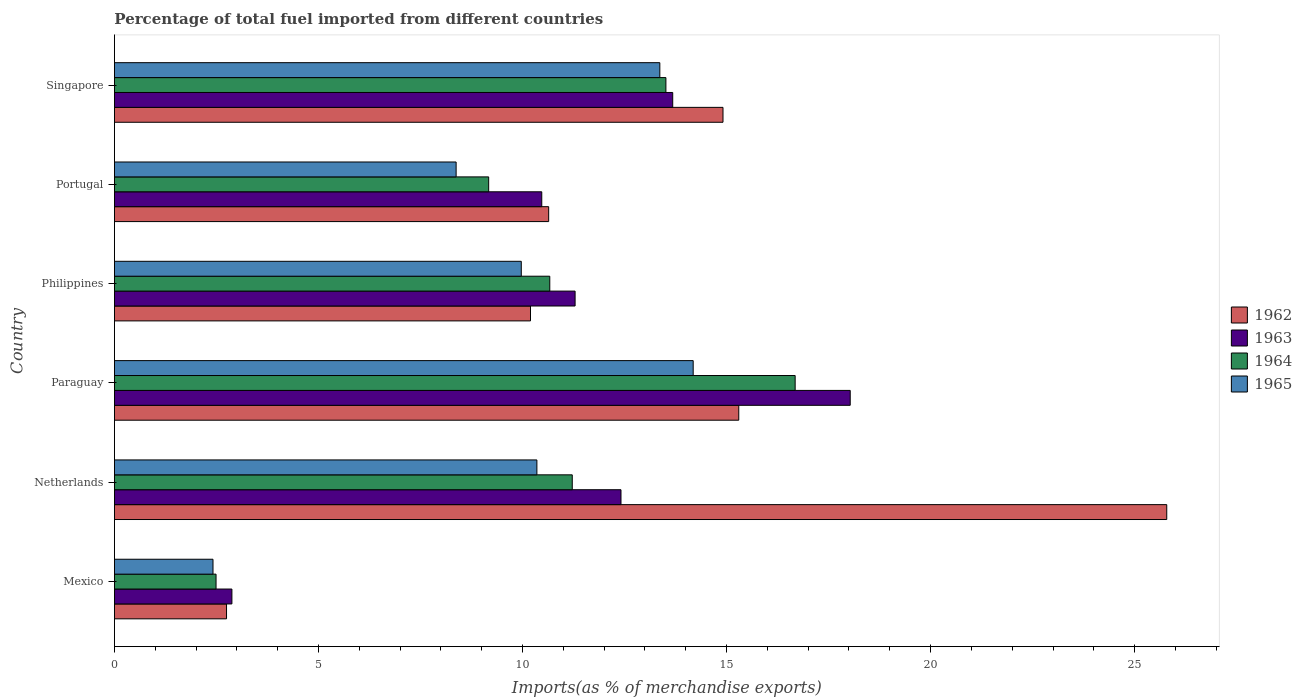How many groups of bars are there?
Provide a succinct answer. 6. Are the number of bars per tick equal to the number of legend labels?
Keep it short and to the point. Yes. Are the number of bars on each tick of the Y-axis equal?
Offer a terse response. Yes. How many bars are there on the 5th tick from the bottom?
Ensure brevity in your answer.  4. What is the label of the 1st group of bars from the top?
Ensure brevity in your answer.  Singapore. What is the percentage of imports to different countries in 1965 in Netherlands?
Provide a short and direct response. 10.35. Across all countries, what is the maximum percentage of imports to different countries in 1964?
Ensure brevity in your answer.  16.68. Across all countries, what is the minimum percentage of imports to different countries in 1965?
Make the answer very short. 2.42. In which country was the percentage of imports to different countries in 1963 maximum?
Provide a short and direct response. Paraguay. In which country was the percentage of imports to different countries in 1965 minimum?
Your response must be concise. Mexico. What is the total percentage of imports to different countries in 1963 in the graph?
Your answer should be very brief. 68.76. What is the difference between the percentage of imports to different countries in 1963 in Mexico and that in Netherlands?
Provide a short and direct response. -9.53. What is the difference between the percentage of imports to different countries in 1964 in Portugal and the percentage of imports to different countries in 1963 in Singapore?
Keep it short and to the point. -4.51. What is the average percentage of imports to different countries in 1963 per country?
Your answer should be compact. 11.46. What is the difference between the percentage of imports to different countries in 1962 and percentage of imports to different countries in 1964 in Mexico?
Keep it short and to the point. 0.26. What is the ratio of the percentage of imports to different countries in 1964 in Mexico to that in Singapore?
Your response must be concise. 0.18. Is the percentage of imports to different countries in 1962 in Philippines less than that in Portugal?
Make the answer very short. Yes. Is the difference between the percentage of imports to different countries in 1962 in Paraguay and Singapore greater than the difference between the percentage of imports to different countries in 1964 in Paraguay and Singapore?
Make the answer very short. No. What is the difference between the highest and the second highest percentage of imports to different countries in 1962?
Keep it short and to the point. 10.49. What is the difference between the highest and the lowest percentage of imports to different countries in 1965?
Keep it short and to the point. 11.77. Is it the case that in every country, the sum of the percentage of imports to different countries in 1965 and percentage of imports to different countries in 1962 is greater than the sum of percentage of imports to different countries in 1964 and percentage of imports to different countries in 1963?
Provide a short and direct response. No. What does the 4th bar from the bottom in Netherlands represents?
Make the answer very short. 1965. Is it the case that in every country, the sum of the percentage of imports to different countries in 1964 and percentage of imports to different countries in 1963 is greater than the percentage of imports to different countries in 1965?
Your answer should be compact. Yes. How many bars are there?
Offer a terse response. 24. Are all the bars in the graph horizontal?
Provide a succinct answer. Yes. Are the values on the major ticks of X-axis written in scientific E-notation?
Provide a short and direct response. No. Does the graph contain any zero values?
Keep it short and to the point. No. Does the graph contain grids?
Give a very brief answer. No. Where does the legend appear in the graph?
Keep it short and to the point. Center right. How many legend labels are there?
Ensure brevity in your answer.  4. How are the legend labels stacked?
Provide a succinct answer. Vertical. What is the title of the graph?
Your answer should be compact. Percentage of total fuel imported from different countries. What is the label or title of the X-axis?
Your answer should be compact. Imports(as % of merchandise exports). What is the Imports(as % of merchandise exports) of 1962 in Mexico?
Provide a succinct answer. 2.75. What is the Imports(as % of merchandise exports) in 1963 in Mexico?
Provide a succinct answer. 2.88. What is the Imports(as % of merchandise exports) in 1964 in Mexico?
Offer a terse response. 2.49. What is the Imports(as % of merchandise exports) in 1965 in Mexico?
Offer a terse response. 2.42. What is the Imports(as % of merchandise exports) in 1962 in Netherlands?
Your answer should be very brief. 25.79. What is the Imports(as % of merchandise exports) in 1963 in Netherlands?
Offer a very short reply. 12.41. What is the Imports(as % of merchandise exports) in 1964 in Netherlands?
Offer a terse response. 11.22. What is the Imports(as % of merchandise exports) of 1965 in Netherlands?
Your response must be concise. 10.35. What is the Imports(as % of merchandise exports) of 1962 in Paraguay?
Provide a short and direct response. 15.3. What is the Imports(as % of merchandise exports) in 1963 in Paraguay?
Your answer should be compact. 18.03. What is the Imports(as % of merchandise exports) in 1964 in Paraguay?
Give a very brief answer. 16.68. What is the Imports(as % of merchandise exports) in 1965 in Paraguay?
Your answer should be compact. 14.18. What is the Imports(as % of merchandise exports) of 1962 in Philippines?
Make the answer very short. 10.2. What is the Imports(as % of merchandise exports) in 1963 in Philippines?
Offer a terse response. 11.29. What is the Imports(as % of merchandise exports) in 1964 in Philippines?
Provide a succinct answer. 10.67. What is the Imports(as % of merchandise exports) of 1965 in Philippines?
Ensure brevity in your answer.  9.97. What is the Imports(as % of merchandise exports) of 1962 in Portugal?
Keep it short and to the point. 10.64. What is the Imports(as % of merchandise exports) in 1963 in Portugal?
Offer a terse response. 10.47. What is the Imports(as % of merchandise exports) in 1964 in Portugal?
Provide a short and direct response. 9.17. What is the Imports(as % of merchandise exports) in 1965 in Portugal?
Give a very brief answer. 8.37. What is the Imports(as % of merchandise exports) in 1962 in Singapore?
Your answer should be very brief. 14.91. What is the Imports(as % of merchandise exports) in 1963 in Singapore?
Provide a succinct answer. 13.68. What is the Imports(as % of merchandise exports) of 1964 in Singapore?
Keep it short and to the point. 13.51. What is the Imports(as % of merchandise exports) of 1965 in Singapore?
Give a very brief answer. 13.37. Across all countries, what is the maximum Imports(as % of merchandise exports) in 1962?
Make the answer very short. 25.79. Across all countries, what is the maximum Imports(as % of merchandise exports) in 1963?
Your response must be concise. 18.03. Across all countries, what is the maximum Imports(as % of merchandise exports) of 1964?
Offer a very short reply. 16.68. Across all countries, what is the maximum Imports(as % of merchandise exports) of 1965?
Keep it short and to the point. 14.18. Across all countries, what is the minimum Imports(as % of merchandise exports) of 1962?
Provide a short and direct response. 2.75. Across all countries, what is the minimum Imports(as % of merchandise exports) of 1963?
Offer a terse response. 2.88. Across all countries, what is the minimum Imports(as % of merchandise exports) of 1964?
Offer a terse response. 2.49. Across all countries, what is the minimum Imports(as % of merchandise exports) of 1965?
Provide a succinct answer. 2.42. What is the total Imports(as % of merchandise exports) in 1962 in the graph?
Your response must be concise. 79.58. What is the total Imports(as % of merchandise exports) of 1963 in the graph?
Your response must be concise. 68.76. What is the total Imports(as % of merchandise exports) of 1964 in the graph?
Give a very brief answer. 63.74. What is the total Imports(as % of merchandise exports) of 1965 in the graph?
Your answer should be compact. 58.66. What is the difference between the Imports(as % of merchandise exports) of 1962 in Mexico and that in Netherlands?
Provide a succinct answer. -23.04. What is the difference between the Imports(as % of merchandise exports) in 1963 in Mexico and that in Netherlands?
Offer a terse response. -9.53. What is the difference between the Imports(as % of merchandise exports) in 1964 in Mexico and that in Netherlands?
Offer a terse response. -8.73. What is the difference between the Imports(as % of merchandise exports) in 1965 in Mexico and that in Netherlands?
Offer a very short reply. -7.94. What is the difference between the Imports(as % of merchandise exports) of 1962 in Mexico and that in Paraguay?
Keep it short and to the point. -12.55. What is the difference between the Imports(as % of merchandise exports) of 1963 in Mexico and that in Paraguay?
Ensure brevity in your answer.  -15.15. What is the difference between the Imports(as % of merchandise exports) of 1964 in Mexico and that in Paraguay?
Keep it short and to the point. -14.19. What is the difference between the Imports(as % of merchandise exports) in 1965 in Mexico and that in Paraguay?
Ensure brevity in your answer.  -11.77. What is the difference between the Imports(as % of merchandise exports) in 1962 in Mexico and that in Philippines?
Offer a terse response. -7.45. What is the difference between the Imports(as % of merchandise exports) in 1963 in Mexico and that in Philippines?
Ensure brevity in your answer.  -8.41. What is the difference between the Imports(as % of merchandise exports) in 1964 in Mexico and that in Philippines?
Make the answer very short. -8.18. What is the difference between the Imports(as % of merchandise exports) in 1965 in Mexico and that in Philippines?
Keep it short and to the point. -7.55. What is the difference between the Imports(as % of merchandise exports) in 1962 in Mexico and that in Portugal?
Offer a terse response. -7.89. What is the difference between the Imports(as % of merchandise exports) in 1963 in Mexico and that in Portugal?
Your answer should be compact. -7.59. What is the difference between the Imports(as % of merchandise exports) in 1964 in Mexico and that in Portugal?
Give a very brief answer. -6.68. What is the difference between the Imports(as % of merchandise exports) of 1965 in Mexico and that in Portugal?
Your answer should be compact. -5.96. What is the difference between the Imports(as % of merchandise exports) in 1962 in Mexico and that in Singapore?
Ensure brevity in your answer.  -12.17. What is the difference between the Imports(as % of merchandise exports) of 1963 in Mexico and that in Singapore?
Offer a terse response. -10.8. What is the difference between the Imports(as % of merchandise exports) in 1964 in Mexico and that in Singapore?
Keep it short and to the point. -11.02. What is the difference between the Imports(as % of merchandise exports) in 1965 in Mexico and that in Singapore?
Offer a terse response. -10.95. What is the difference between the Imports(as % of merchandise exports) of 1962 in Netherlands and that in Paraguay?
Offer a very short reply. 10.49. What is the difference between the Imports(as % of merchandise exports) of 1963 in Netherlands and that in Paraguay?
Provide a short and direct response. -5.62. What is the difference between the Imports(as % of merchandise exports) in 1964 in Netherlands and that in Paraguay?
Offer a very short reply. -5.46. What is the difference between the Imports(as % of merchandise exports) of 1965 in Netherlands and that in Paraguay?
Your answer should be compact. -3.83. What is the difference between the Imports(as % of merchandise exports) in 1962 in Netherlands and that in Philippines?
Ensure brevity in your answer.  15.59. What is the difference between the Imports(as % of merchandise exports) of 1963 in Netherlands and that in Philippines?
Your response must be concise. 1.12. What is the difference between the Imports(as % of merchandise exports) of 1964 in Netherlands and that in Philippines?
Keep it short and to the point. 0.55. What is the difference between the Imports(as % of merchandise exports) of 1965 in Netherlands and that in Philippines?
Offer a terse response. 0.38. What is the difference between the Imports(as % of merchandise exports) in 1962 in Netherlands and that in Portugal?
Offer a very short reply. 15.15. What is the difference between the Imports(as % of merchandise exports) of 1963 in Netherlands and that in Portugal?
Keep it short and to the point. 1.94. What is the difference between the Imports(as % of merchandise exports) in 1964 in Netherlands and that in Portugal?
Make the answer very short. 2.05. What is the difference between the Imports(as % of merchandise exports) of 1965 in Netherlands and that in Portugal?
Ensure brevity in your answer.  1.98. What is the difference between the Imports(as % of merchandise exports) in 1962 in Netherlands and that in Singapore?
Offer a terse response. 10.87. What is the difference between the Imports(as % of merchandise exports) in 1963 in Netherlands and that in Singapore?
Your answer should be compact. -1.27. What is the difference between the Imports(as % of merchandise exports) of 1964 in Netherlands and that in Singapore?
Keep it short and to the point. -2.29. What is the difference between the Imports(as % of merchandise exports) of 1965 in Netherlands and that in Singapore?
Your answer should be compact. -3.01. What is the difference between the Imports(as % of merchandise exports) in 1962 in Paraguay and that in Philippines?
Give a very brief answer. 5.1. What is the difference between the Imports(as % of merchandise exports) in 1963 in Paraguay and that in Philippines?
Ensure brevity in your answer.  6.74. What is the difference between the Imports(as % of merchandise exports) in 1964 in Paraguay and that in Philippines?
Provide a short and direct response. 6.01. What is the difference between the Imports(as % of merchandise exports) of 1965 in Paraguay and that in Philippines?
Ensure brevity in your answer.  4.21. What is the difference between the Imports(as % of merchandise exports) in 1962 in Paraguay and that in Portugal?
Offer a terse response. 4.66. What is the difference between the Imports(as % of merchandise exports) of 1963 in Paraguay and that in Portugal?
Offer a terse response. 7.56. What is the difference between the Imports(as % of merchandise exports) in 1964 in Paraguay and that in Portugal?
Provide a short and direct response. 7.51. What is the difference between the Imports(as % of merchandise exports) in 1965 in Paraguay and that in Portugal?
Your answer should be compact. 5.81. What is the difference between the Imports(as % of merchandise exports) of 1962 in Paraguay and that in Singapore?
Your answer should be very brief. 0.39. What is the difference between the Imports(as % of merchandise exports) in 1963 in Paraguay and that in Singapore?
Keep it short and to the point. 4.35. What is the difference between the Imports(as % of merchandise exports) of 1964 in Paraguay and that in Singapore?
Your answer should be very brief. 3.17. What is the difference between the Imports(as % of merchandise exports) of 1965 in Paraguay and that in Singapore?
Make the answer very short. 0.82. What is the difference between the Imports(as % of merchandise exports) in 1962 in Philippines and that in Portugal?
Provide a short and direct response. -0.45. What is the difference between the Imports(as % of merchandise exports) in 1963 in Philippines and that in Portugal?
Give a very brief answer. 0.82. What is the difference between the Imports(as % of merchandise exports) of 1964 in Philippines and that in Portugal?
Offer a very short reply. 1.5. What is the difference between the Imports(as % of merchandise exports) of 1965 in Philippines and that in Portugal?
Your response must be concise. 1.6. What is the difference between the Imports(as % of merchandise exports) in 1962 in Philippines and that in Singapore?
Your answer should be very brief. -4.72. What is the difference between the Imports(as % of merchandise exports) in 1963 in Philippines and that in Singapore?
Give a very brief answer. -2.39. What is the difference between the Imports(as % of merchandise exports) of 1964 in Philippines and that in Singapore?
Your answer should be very brief. -2.85. What is the difference between the Imports(as % of merchandise exports) in 1965 in Philippines and that in Singapore?
Your answer should be compact. -3.4. What is the difference between the Imports(as % of merchandise exports) in 1962 in Portugal and that in Singapore?
Ensure brevity in your answer.  -4.27. What is the difference between the Imports(as % of merchandise exports) in 1963 in Portugal and that in Singapore?
Your answer should be very brief. -3.21. What is the difference between the Imports(as % of merchandise exports) of 1964 in Portugal and that in Singapore?
Your answer should be very brief. -4.34. What is the difference between the Imports(as % of merchandise exports) of 1965 in Portugal and that in Singapore?
Give a very brief answer. -4.99. What is the difference between the Imports(as % of merchandise exports) in 1962 in Mexico and the Imports(as % of merchandise exports) in 1963 in Netherlands?
Your answer should be very brief. -9.67. What is the difference between the Imports(as % of merchandise exports) of 1962 in Mexico and the Imports(as % of merchandise exports) of 1964 in Netherlands?
Keep it short and to the point. -8.47. What is the difference between the Imports(as % of merchandise exports) of 1962 in Mexico and the Imports(as % of merchandise exports) of 1965 in Netherlands?
Offer a terse response. -7.61. What is the difference between the Imports(as % of merchandise exports) of 1963 in Mexico and the Imports(as % of merchandise exports) of 1964 in Netherlands?
Your answer should be compact. -8.34. What is the difference between the Imports(as % of merchandise exports) of 1963 in Mexico and the Imports(as % of merchandise exports) of 1965 in Netherlands?
Ensure brevity in your answer.  -7.47. What is the difference between the Imports(as % of merchandise exports) in 1964 in Mexico and the Imports(as % of merchandise exports) in 1965 in Netherlands?
Keep it short and to the point. -7.86. What is the difference between the Imports(as % of merchandise exports) in 1962 in Mexico and the Imports(as % of merchandise exports) in 1963 in Paraguay?
Your answer should be compact. -15.28. What is the difference between the Imports(as % of merchandise exports) in 1962 in Mexico and the Imports(as % of merchandise exports) in 1964 in Paraguay?
Provide a short and direct response. -13.93. What is the difference between the Imports(as % of merchandise exports) of 1962 in Mexico and the Imports(as % of merchandise exports) of 1965 in Paraguay?
Provide a succinct answer. -11.44. What is the difference between the Imports(as % of merchandise exports) of 1963 in Mexico and the Imports(as % of merchandise exports) of 1964 in Paraguay?
Provide a short and direct response. -13.8. What is the difference between the Imports(as % of merchandise exports) in 1963 in Mexico and the Imports(as % of merchandise exports) in 1965 in Paraguay?
Offer a terse response. -11.3. What is the difference between the Imports(as % of merchandise exports) in 1964 in Mexico and the Imports(as % of merchandise exports) in 1965 in Paraguay?
Provide a succinct answer. -11.69. What is the difference between the Imports(as % of merchandise exports) of 1962 in Mexico and the Imports(as % of merchandise exports) of 1963 in Philippines?
Keep it short and to the point. -8.54. What is the difference between the Imports(as % of merchandise exports) in 1962 in Mexico and the Imports(as % of merchandise exports) in 1964 in Philippines?
Your answer should be very brief. -7.92. What is the difference between the Imports(as % of merchandise exports) in 1962 in Mexico and the Imports(as % of merchandise exports) in 1965 in Philippines?
Your response must be concise. -7.22. What is the difference between the Imports(as % of merchandise exports) of 1963 in Mexico and the Imports(as % of merchandise exports) of 1964 in Philippines?
Your answer should be very brief. -7.79. What is the difference between the Imports(as % of merchandise exports) of 1963 in Mexico and the Imports(as % of merchandise exports) of 1965 in Philippines?
Make the answer very short. -7.09. What is the difference between the Imports(as % of merchandise exports) of 1964 in Mexico and the Imports(as % of merchandise exports) of 1965 in Philippines?
Give a very brief answer. -7.48. What is the difference between the Imports(as % of merchandise exports) in 1962 in Mexico and the Imports(as % of merchandise exports) in 1963 in Portugal?
Offer a terse response. -7.73. What is the difference between the Imports(as % of merchandise exports) in 1962 in Mexico and the Imports(as % of merchandise exports) in 1964 in Portugal?
Offer a very short reply. -6.42. What is the difference between the Imports(as % of merchandise exports) in 1962 in Mexico and the Imports(as % of merchandise exports) in 1965 in Portugal?
Offer a terse response. -5.63. What is the difference between the Imports(as % of merchandise exports) in 1963 in Mexico and the Imports(as % of merchandise exports) in 1964 in Portugal?
Ensure brevity in your answer.  -6.29. What is the difference between the Imports(as % of merchandise exports) of 1963 in Mexico and the Imports(as % of merchandise exports) of 1965 in Portugal?
Offer a terse response. -5.49. What is the difference between the Imports(as % of merchandise exports) in 1964 in Mexico and the Imports(as % of merchandise exports) in 1965 in Portugal?
Offer a very short reply. -5.88. What is the difference between the Imports(as % of merchandise exports) of 1962 in Mexico and the Imports(as % of merchandise exports) of 1963 in Singapore?
Ensure brevity in your answer.  -10.93. What is the difference between the Imports(as % of merchandise exports) in 1962 in Mexico and the Imports(as % of merchandise exports) in 1964 in Singapore?
Make the answer very short. -10.77. What is the difference between the Imports(as % of merchandise exports) in 1962 in Mexico and the Imports(as % of merchandise exports) in 1965 in Singapore?
Your response must be concise. -10.62. What is the difference between the Imports(as % of merchandise exports) in 1963 in Mexico and the Imports(as % of merchandise exports) in 1964 in Singapore?
Offer a very short reply. -10.64. What is the difference between the Imports(as % of merchandise exports) of 1963 in Mexico and the Imports(as % of merchandise exports) of 1965 in Singapore?
Provide a succinct answer. -10.49. What is the difference between the Imports(as % of merchandise exports) of 1964 in Mexico and the Imports(as % of merchandise exports) of 1965 in Singapore?
Your answer should be compact. -10.88. What is the difference between the Imports(as % of merchandise exports) of 1962 in Netherlands and the Imports(as % of merchandise exports) of 1963 in Paraguay?
Offer a terse response. 7.76. What is the difference between the Imports(as % of merchandise exports) in 1962 in Netherlands and the Imports(as % of merchandise exports) in 1964 in Paraguay?
Ensure brevity in your answer.  9.11. What is the difference between the Imports(as % of merchandise exports) of 1962 in Netherlands and the Imports(as % of merchandise exports) of 1965 in Paraguay?
Provide a succinct answer. 11.6. What is the difference between the Imports(as % of merchandise exports) in 1963 in Netherlands and the Imports(as % of merchandise exports) in 1964 in Paraguay?
Your answer should be compact. -4.27. What is the difference between the Imports(as % of merchandise exports) of 1963 in Netherlands and the Imports(as % of merchandise exports) of 1965 in Paraguay?
Provide a short and direct response. -1.77. What is the difference between the Imports(as % of merchandise exports) of 1964 in Netherlands and the Imports(as % of merchandise exports) of 1965 in Paraguay?
Give a very brief answer. -2.96. What is the difference between the Imports(as % of merchandise exports) in 1962 in Netherlands and the Imports(as % of merchandise exports) in 1963 in Philippines?
Keep it short and to the point. 14.5. What is the difference between the Imports(as % of merchandise exports) in 1962 in Netherlands and the Imports(as % of merchandise exports) in 1964 in Philippines?
Your response must be concise. 15.12. What is the difference between the Imports(as % of merchandise exports) of 1962 in Netherlands and the Imports(as % of merchandise exports) of 1965 in Philippines?
Your answer should be compact. 15.82. What is the difference between the Imports(as % of merchandise exports) of 1963 in Netherlands and the Imports(as % of merchandise exports) of 1964 in Philippines?
Provide a short and direct response. 1.74. What is the difference between the Imports(as % of merchandise exports) in 1963 in Netherlands and the Imports(as % of merchandise exports) in 1965 in Philippines?
Offer a very short reply. 2.44. What is the difference between the Imports(as % of merchandise exports) of 1964 in Netherlands and the Imports(as % of merchandise exports) of 1965 in Philippines?
Your response must be concise. 1.25. What is the difference between the Imports(as % of merchandise exports) of 1962 in Netherlands and the Imports(as % of merchandise exports) of 1963 in Portugal?
Make the answer very short. 15.32. What is the difference between the Imports(as % of merchandise exports) in 1962 in Netherlands and the Imports(as % of merchandise exports) in 1964 in Portugal?
Your answer should be compact. 16.62. What is the difference between the Imports(as % of merchandise exports) in 1962 in Netherlands and the Imports(as % of merchandise exports) in 1965 in Portugal?
Your response must be concise. 17.41. What is the difference between the Imports(as % of merchandise exports) in 1963 in Netherlands and the Imports(as % of merchandise exports) in 1964 in Portugal?
Make the answer very short. 3.24. What is the difference between the Imports(as % of merchandise exports) of 1963 in Netherlands and the Imports(as % of merchandise exports) of 1965 in Portugal?
Give a very brief answer. 4.04. What is the difference between the Imports(as % of merchandise exports) in 1964 in Netherlands and the Imports(as % of merchandise exports) in 1965 in Portugal?
Your answer should be very brief. 2.85. What is the difference between the Imports(as % of merchandise exports) in 1962 in Netherlands and the Imports(as % of merchandise exports) in 1963 in Singapore?
Provide a succinct answer. 12.11. What is the difference between the Imports(as % of merchandise exports) in 1962 in Netherlands and the Imports(as % of merchandise exports) in 1964 in Singapore?
Ensure brevity in your answer.  12.27. What is the difference between the Imports(as % of merchandise exports) in 1962 in Netherlands and the Imports(as % of merchandise exports) in 1965 in Singapore?
Offer a terse response. 12.42. What is the difference between the Imports(as % of merchandise exports) of 1963 in Netherlands and the Imports(as % of merchandise exports) of 1964 in Singapore?
Ensure brevity in your answer.  -1.1. What is the difference between the Imports(as % of merchandise exports) of 1963 in Netherlands and the Imports(as % of merchandise exports) of 1965 in Singapore?
Offer a very short reply. -0.95. What is the difference between the Imports(as % of merchandise exports) in 1964 in Netherlands and the Imports(as % of merchandise exports) in 1965 in Singapore?
Offer a very short reply. -2.15. What is the difference between the Imports(as % of merchandise exports) in 1962 in Paraguay and the Imports(as % of merchandise exports) in 1963 in Philippines?
Ensure brevity in your answer.  4.01. What is the difference between the Imports(as % of merchandise exports) of 1962 in Paraguay and the Imports(as % of merchandise exports) of 1964 in Philippines?
Your answer should be very brief. 4.63. What is the difference between the Imports(as % of merchandise exports) in 1962 in Paraguay and the Imports(as % of merchandise exports) in 1965 in Philippines?
Your answer should be very brief. 5.33. What is the difference between the Imports(as % of merchandise exports) in 1963 in Paraguay and the Imports(as % of merchandise exports) in 1964 in Philippines?
Ensure brevity in your answer.  7.36. What is the difference between the Imports(as % of merchandise exports) of 1963 in Paraguay and the Imports(as % of merchandise exports) of 1965 in Philippines?
Your answer should be compact. 8.06. What is the difference between the Imports(as % of merchandise exports) of 1964 in Paraguay and the Imports(as % of merchandise exports) of 1965 in Philippines?
Make the answer very short. 6.71. What is the difference between the Imports(as % of merchandise exports) of 1962 in Paraguay and the Imports(as % of merchandise exports) of 1963 in Portugal?
Provide a short and direct response. 4.83. What is the difference between the Imports(as % of merchandise exports) in 1962 in Paraguay and the Imports(as % of merchandise exports) in 1964 in Portugal?
Your answer should be very brief. 6.13. What is the difference between the Imports(as % of merchandise exports) of 1962 in Paraguay and the Imports(as % of merchandise exports) of 1965 in Portugal?
Ensure brevity in your answer.  6.93. What is the difference between the Imports(as % of merchandise exports) in 1963 in Paraguay and the Imports(as % of merchandise exports) in 1964 in Portugal?
Ensure brevity in your answer.  8.86. What is the difference between the Imports(as % of merchandise exports) of 1963 in Paraguay and the Imports(as % of merchandise exports) of 1965 in Portugal?
Your response must be concise. 9.66. What is the difference between the Imports(as % of merchandise exports) of 1964 in Paraguay and the Imports(as % of merchandise exports) of 1965 in Portugal?
Your response must be concise. 8.31. What is the difference between the Imports(as % of merchandise exports) of 1962 in Paraguay and the Imports(as % of merchandise exports) of 1963 in Singapore?
Make the answer very short. 1.62. What is the difference between the Imports(as % of merchandise exports) in 1962 in Paraguay and the Imports(as % of merchandise exports) in 1964 in Singapore?
Your answer should be compact. 1.79. What is the difference between the Imports(as % of merchandise exports) in 1962 in Paraguay and the Imports(as % of merchandise exports) in 1965 in Singapore?
Ensure brevity in your answer.  1.93. What is the difference between the Imports(as % of merchandise exports) in 1963 in Paraguay and the Imports(as % of merchandise exports) in 1964 in Singapore?
Offer a terse response. 4.52. What is the difference between the Imports(as % of merchandise exports) of 1963 in Paraguay and the Imports(as % of merchandise exports) of 1965 in Singapore?
Offer a terse response. 4.67. What is the difference between the Imports(as % of merchandise exports) of 1964 in Paraguay and the Imports(as % of merchandise exports) of 1965 in Singapore?
Ensure brevity in your answer.  3.32. What is the difference between the Imports(as % of merchandise exports) in 1962 in Philippines and the Imports(as % of merchandise exports) in 1963 in Portugal?
Your answer should be compact. -0.28. What is the difference between the Imports(as % of merchandise exports) in 1962 in Philippines and the Imports(as % of merchandise exports) in 1964 in Portugal?
Make the answer very short. 1.03. What is the difference between the Imports(as % of merchandise exports) in 1962 in Philippines and the Imports(as % of merchandise exports) in 1965 in Portugal?
Offer a very short reply. 1.82. What is the difference between the Imports(as % of merchandise exports) in 1963 in Philippines and the Imports(as % of merchandise exports) in 1964 in Portugal?
Offer a terse response. 2.12. What is the difference between the Imports(as % of merchandise exports) in 1963 in Philippines and the Imports(as % of merchandise exports) in 1965 in Portugal?
Provide a short and direct response. 2.92. What is the difference between the Imports(as % of merchandise exports) of 1964 in Philippines and the Imports(as % of merchandise exports) of 1965 in Portugal?
Your answer should be very brief. 2.3. What is the difference between the Imports(as % of merchandise exports) in 1962 in Philippines and the Imports(as % of merchandise exports) in 1963 in Singapore?
Make the answer very short. -3.49. What is the difference between the Imports(as % of merchandise exports) in 1962 in Philippines and the Imports(as % of merchandise exports) in 1964 in Singapore?
Offer a very short reply. -3.32. What is the difference between the Imports(as % of merchandise exports) of 1962 in Philippines and the Imports(as % of merchandise exports) of 1965 in Singapore?
Make the answer very short. -3.17. What is the difference between the Imports(as % of merchandise exports) of 1963 in Philippines and the Imports(as % of merchandise exports) of 1964 in Singapore?
Offer a terse response. -2.23. What is the difference between the Imports(as % of merchandise exports) in 1963 in Philippines and the Imports(as % of merchandise exports) in 1965 in Singapore?
Your answer should be very brief. -2.08. What is the difference between the Imports(as % of merchandise exports) in 1964 in Philippines and the Imports(as % of merchandise exports) in 1965 in Singapore?
Your answer should be compact. -2.7. What is the difference between the Imports(as % of merchandise exports) of 1962 in Portugal and the Imports(as % of merchandise exports) of 1963 in Singapore?
Your answer should be very brief. -3.04. What is the difference between the Imports(as % of merchandise exports) in 1962 in Portugal and the Imports(as % of merchandise exports) in 1964 in Singapore?
Offer a very short reply. -2.87. What is the difference between the Imports(as % of merchandise exports) in 1962 in Portugal and the Imports(as % of merchandise exports) in 1965 in Singapore?
Give a very brief answer. -2.72. What is the difference between the Imports(as % of merchandise exports) of 1963 in Portugal and the Imports(as % of merchandise exports) of 1964 in Singapore?
Provide a short and direct response. -3.04. What is the difference between the Imports(as % of merchandise exports) of 1963 in Portugal and the Imports(as % of merchandise exports) of 1965 in Singapore?
Offer a terse response. -2.89. What is the difference between the Imports(as % of merchandise exports) in 1964 in Portugal and the Imports(as % of merchandise exports) in 1965 in Singapore?
Give a very brief answer. -4.19. What is the average Imports(as % of merchandise exports) in 1962 per country?
Offer a very short reply. 13.26. What is the average Imports(as % of merchandise exports) in 1963 per country?
Provide a short and direct response. 11.46. What is the average Imports(as % of merchandise exports) in 1964 per country?
Ensure brevity in your answer.  10.62. What is the average Imports(as % of merchandise exports) of 1965 per country?
Your response must be concise. 9.78. What is the difference between the Imports(as % of merchandise exports) of 1962 and Imports(as % of merchandise exports) of 1963 in Mexico?
Keep it short and to the point. -0.13. What is the difference between the Imports(as % of merchandise exports) in 1962 and Imports(as % of merchandise exports) in 1964 in Mexico?
Offer a very short reply. 0.26. What is the difference between the Imports(as % of merchandise exports) of 1962 and Imports(as % of merchandise exports) of 1965 in Mexico?
Give a very brief answer. 0.33. What is the difference between the Imports(as % of merchandise exports) of 1963 and Imports(as % of merchandise exports) of 1964 in Mexico?
Offer a terse response. 0.39. What is the difference between the Imports(as % of merchandise exports) of 1963 and Imports(as % of merchandise exports) of 1965 in Mexico?
Keep it short and to the point. 0.46. What is the difference between the Imports(as % of merchandise exports) of 1964 and Imports(as % of merchandise exports) of 1965 in Mexico?
Give a very brief answer. 0.07. What is the difference between the Imports(as % of merchandise exports) of 1962 and Imports(as % of merchandise exports) of 1963 in Netherlands?
Offer a very short reply. 13.37. What is the difference between the Imports(as % of merchandise exports) of 1962 and Imports(as % of merchandise exports) of 1964 in Netherlands?
Make the answer very short. 14.57. What is the difference between the Imports(as % of merchandise exports) of 1962 and Imports(as % of merchandise exports) of 1965 in Netherlands?
Make the answer very short. 15.43. What is the difference between the Imports(as % of merchandise exports) in 1963 and Imports(as % of merchandise exports) in 1964 in Netherlands?
Offer a very short reply. 1.19. What is the difference between the Imports(as % of merchandise exports) in 1963 and Imports(as % of merchandise exports) in 1965 in Netherlands?
Your answer should be very brief. 2.06. What is the difference between the Imports(as % of merchandise exports) in 1964 and Imports(as % of merchandise exports) in 1965 in Netherlands?
Make the answer very short. 0.87. What is the difference between the Imports(as % of merchandise exports) in 1962 and Imports(as % of merchandise exports) in 1963 in Paraguay?
Provide a short and direct response. -2.73. What is the difference between the Imports(as % of merchandise exports) in 1962 and Imports(as % of merchandise exports) in 1964 in Paraguay?
Give a very brief answer. -1.38. What is the difference between the Imports(as % of merchandise exports) in 1962 and Imports(as % of merchandise exports) in 1965 in Paraguay?
Give a very brief answer. 1.12. What is the difference between the Imports(as % of merchandise exports) of 1963 and Imports(as % of merchandise exports) of 1964 in Paraguay?
Make the answer very short. 1.35. What is the difference between the Imports(as % of merchandise exports) of 1963 and Imports(as % of merchandise exports) of 1965 in Paraguay?
Offer a terse response. 3.85. What is the difference between the Imports(as % of merchandise exports) of 1964 and Imports(as % of merchandise exports) of 1965 in Paraguay?
Make the answer very short. 2.5. What is the difference between the Imports(as % of merchandise exports) of 1962 and Imports(as % of merchandise exports) of 1963 in Philippines?
Offer a terse response. -1.09. What is the difference between the Imports(as % of merchandise exports) in 1962 and Imports(as % of merchandise exports) in 1964 in Philippines?
Your answer should be compact. -0.47. What is the difference between the Imports(as % of merchandise exports) in 1962 and Imports(as % of merchandise exports) in 1965 in Philippines?
Ensure brevity in your answer.  0.23. What is the difference between the Imports(as % of merchandise exports) in 1963 and Imports(as % of merchandise exports) in 1964 in Philippines?
Ensure brevity in your answer.  0.62. What is the difference between the Imports(as % of merchandise exports) of 1963 and Imports(as % of merchandise exports) of 1965 in Philippines?
Provide a short and direct response. 1.32. What is the difference between the Imports(as % of merchandise exports) in 1964 and Imports(as % of merchandise exports) in 1965 in Philippines?
Offer a terse response. 0.7. What is the difference between the Imports(as % of merchandise exports) of 1962 and Imports(as % of merchandise exports) of 1963 in Portugal?
Offer a terse response. 0.17. What is the difference between the Imports(as % of merchandise exports) of 1962 and Imports(as % of merchandise exports) of 1964 in Portugal?
Provide a succinct answer. 1.47. What is the difference between the Imports(as % of merchandise exports) of 1962 and Imports(as % of merchandise exports) of 1965 in Portugal?
Your response must be concise. 2.27. What is the difference between the Imports(as % of merchandise exports) in 1963 and Imports(as % of merchandise exports) in 1964 in Portugal?
Your answer should be very brief. 1.3. What is the difference between the Imports(as % of merchandise exports) in 1963 and Imports(as % of merchandise exports) in 1965 in Portugal?
Offer a terse response. 2.1. What is the difference between the Imports(as % of merchandise exports) of 1964 and Imports(as % of merchandise exports) of 1965 in Portugal?
Provide a short and direct response. 0.8. What is the difference between the Imports(as % of merchandise exports) in 1962 and Imports(as % of merchandise exports) in 1963 in Singapore?
Provide a succinct answer. 1.23. What is the difference between the Imports(as % of merchandise exports) of 1962 and Imports(as % of merchandise exports) of 1964 in Singapore?
Your response must be concise. 1.4. What is the difference between the Imports(as % of merchandise exports) in 1962 and Imports(as % of merchandise exports) in 1965 in Singapore?
Give a very brief answer. 1.55. What is the difference between the Imports(as % of merchandise exports) of 1963 and Imports(as % of merchandise exports) of 1964 in Singapore?
Give a very brief answer. 0.17. What is the difference between the Imports(as % of merchandise exports) in 1963 and Imports(as % of merchandise exports) in 1965 in Singapore?
Keep it short and to the point. 0.32. What is the difference between the Imports(as % of merchandise exports) of 1964 and Imports(as % of merchandise exports) of 1965 in Singapore?
Provide a succinct answer. 0.15. What is the ratio of the Imports(as % of merchandise exports) of 1962 in Mexico to that in Netherlands?
Keep it short and to the point. 0.11. What is the ratio of the Imports(as % of merchandise exports) of 1963 in Mexico to that in Netherlands?
Your answer should be very brief. 0.23. What is the ratio of the Imports(as % of merchandise exports) in 1964 in Mexico to that in Netherlands?
Your answer should be compact. 0.22. What is the ratio of the Imports(as % of merchandise exports) of 1965 in Mexico to that in Netherlands?
Ensure brevity in your answer.  0.23. What is the ratio of the Imports(as % of merchandise exports) of 1962 in Mexico to that in Paraguay?
Your answer should be very brief. 0.18. What is the ratio of the Imports(as % of merchandise exports) of 1963 in Mexico to that in Paraguay?
Your response must be concise. 0.16. What is the ratio of the Imports(as % of merchandise exports) of 1964 in Mexico to that in Paraguay?
Offer a terse response. 0.15. What is the ratio of the Imports(as % of merchandise exports) of 1965 in Mexico to that in Paraguay?
Give a very brief answer. 0.17. What is the ratio of the Imports(as % of merchandise exports) of 1962 in Mexico to that in Philippines?
Keep it short and to the point. 0.27. What is the ratio of the Imports(as % of merchandise exports) in 1963 in Mexico to that in Philippines?
Ensure brevity in your answer.  0.26. What is the ratio of the Imports(as % of merchandise exports) of 1964 in Mexico to that in Philippines?
Offer a terse response. 0.23. What is the ratio of the Imports(as % of merchandise exports) in 1965 in Mexico to that in Philippines?
Your answer should be compact. 0.24. What is the ratio of the Imports(as % of merchandise exports) in 1962 in Mexico to that in Portugal?
Provide a succinct answer. 0.26. What is the ratio of the Imports(as % of merchandise exports) of 1963 in Mexico to that in Portugal?
Give a very brief answer. 0.27. What is the ratio of the Imports(as % of merchandise exports) in 1964 in Mexico to that in Portugal?
Offer a terse response. 0.27. What is the ratio of the Imports(as % of merchandise exports) in 1965 in Mexico to that in Portugal?
Keep it short and to the point. 0.29. What is the ratio of the Imports(as % of merchandise exports) in 1962 in Mexico to that in Singapore?
Keep it short and to the point. 0.18. What is the ratio of the Imports(as % of merchandise exports) of 1963 in Mexico to that in Singapore?
Provide a succinct answer. 0.21. What is the ratio of the Imports(as % of merchandise exports) of 1964 in Mexico to that in Singapore?
Offer a terse response. 0.18. What is the ratio of the Imports(as % of merchandise exports) in 1965 in Mexico to that in Singapore?
Provide a short and direct response. 0.18. What is the ratio of the Imports(as % of merchandise exports) in 1962 in Netherlands to that in Paraguay?
Provide a short and direct response. 1.69. What is the ratio of the Imports(as % of merchandise exports) of 1963 in Netherlands to that in Paraguay?
Make the answer very short. 0.69. What is the ratio of the Imports(as % of merchandise exports) in 1964 in Netherlands to that in Paraguay?
Provide a succinct answer. 0.67. What is the ratio of the Imports(as % of merchandise exports) in 1965 in Netherlands to that in Paraguay?
Offer a terse response. 0.73. What is the ratio of the Imports(as % of merchandise exports) of 1962 in Netherlands to that in Philippines?
Your answer should be compact. 2.53. What is the ratio of the Imports(as % of merchandise exports) in 1963 in Netherlands to that in Philippines?
Offer a very short reply. 1.1. What is the ratio of the Imports(as % of merchandise exports) in 1964 in Netherlands to that in Philippines?
Give a very brief answer. 1.05. What is the ratio of the Imports(as % of merchandise exports) of 1965 in Netherlands to that in Philippines?
Your answer should be compact. 1.04. What is the ratio of the Imports(as % of merchandise exports) in 1962 in Netherlands to that in Portugal?
Ensure brevity in your answer.  2.42. What is the ratio of the Imports(as % of merchandise exports) in 1963 in Netherlands to that in Portugal?
Provide a short and direct response. 1.19. What is the ratio of the Imports(as % of merchandise exports) of 1964 in Netherlands to that in Portugal?
Make the answer very short. 1.22. What is the ratio of the Imports(as % of merchandise exports) in 1965 in Netherlands to that in Portugal?
Make the answer very short. 1.24. What is the ratio of the Imports(as % of merchandise exports) in 1962 in Netherlands to that in Singapore?
Give a very brief answer. 1.73. What is the ratio of the Imports(as % of merchandise exports) of 1963 in Netherlands to that in Singapore?
Make the answer very short. 0.91. What is the ratio of the Imports(as % of merchandise exports) in 1964 in Netherlands to that in Singapore?
Provide a succinct answer. 0.83. What is the ratio of the Imports(as % of merchandise exports) in 1965 in Netherlands to that in Singapore?
Ensure brevity in your answer.  0.77. What is the ratio of the Imports(as % of merchandise exports) in 1962 in Paraguay to that in Philippines?
Offer a very short reply. 1.5. What is the ratio of the Imports(as % of merchandise exports) of 1963 in Paraguay to that in Philippines?
Offer a very short reply. 1.6. What is the ratio of the Imports(as % of merchandise exports) in 1964 in Paraguay to that in Philippines?
Offer a very short reply. 1.56. What is the ratio of the Imports(as % of merchandise exports) in 1965 in Paraguay to that in Philippines?
Ensure brevity in your answer.  1.42. What is the ratio of the Imports(as % of merchandise exports) in 1962 in Paraguay to that in Portugal?
Ensure brevity in your answer.  1.44. What is the ratio of the Imports(as % of merchandise exports) of 1963 in Paraguay to that in Portugal?
Ensure brevity in your answer.  1.72. What is the ratio of the Imports(as % of merchandise exports) of 1964 in Paraguay to that in Portugal?
Provide a short and direct response. 1.82. What is the ratio of the Imports(as % of merchandise exports) in 1965 in Paraguay to that in Portugal?
Your answer should be very brief. 1.69. What is the ratio of the Imports(as % of merchandise exports) of 1962 in Paraguay to that in Singapore?
Ensure brevity in your answer.  1.03. What is the ratio of the Imports(as % of merchandise exports) of 1963 in Paraguay to that in Singapore?
Ensure brevity in your answer.  1.32. What is the ratio of the Imports(as % of merchandise exports) of 1964 in Paraguay to that in Singapore?
Your answer should be compact. 1.23. What is the ratio of the Imports(as % of merchandise exports) of 1965 in Paraguay to that in Singapore?
Make the answer very short. 1.06. What is the ratio of the Imports(as % of merchandise exports) of 1962 in Philippines to that in Portugal?
Provide a short and direct response. 0.96. What is the ratio of the Imports(as % of merchandise exports) in 1963 in Philippines to that in Portugal?
Offer a terse response. 1.08. What is the ratio of the Imports(as % of merchandise exports) of 1964 in Philippines to that in Portugal?
Ensure brevity in your answer.  1.16. What is the ratio of the Imports(as % of merchandise exports) of 1965 in Philippines to that in Portugal?
Ensure brevity in your answer.  1.19. What is the ratio of the Imports(as % of merchandise exports) in 1962 in Philippines to that in Singapore?
Give a very brief answer. 0.68. What is the ratio of the Imports(as % of merchandise exports) in 1963 in Philippines to that in Singapore?
Keep it short and to the point. 0.83. What is the ratio of the Imports(as % of merchandise exports) in 1964 in Philippines to that in Singapore?
Your answer should be very brief. 0.79. What is the ratio of the Imports(as % of merchandise exports) in 1965 in Philippines to that in Singapore?
Keep it short and to the point. 0.75. What is the ratio of the Imports(as % of merchandise exports) of 1962 in Portugal to that in Singapore?
Ensure brevity in your answer.  0.71. What is the ratio of the Imports(as % of merchandise exports) in 1963 in Portugal to that in Singapore?
Provide a short and direct response. 0.77. What is the ratio of the Imports(as % of merchandise exports) of 1964 in Portugal to that in Singapore?
Your answer should be compact. 0.68. What is the ratio of the Imports(as % of merchandise exports) in 1965 in Portugal to that in Singapore?
Offer a very short reply. 0.63. What is the difference between the highest and the second highest Imports(as % of merchandise exports) of 1962?
Keep it short and to the point. 10.49. What is the difference between the highest and the second highest Imports(as % of merchandise exports) in 1963?
Offer a very short reply. 4.35. What is the difference between the highest and the second highest Imports(as % of merchandise exports) in 1964?
Your answer should be very brief. 3.17. What is the difference between the highest and the second highest Imports(as % of merchandise exports) in 1965?
Offer a very short reply. 0.82. What is the difference between the highest and the lowest Imports(as % of merchandise exports) of 1962?
Ensure brevity in your answer.  23.04. What is the difference between the highest and the lowest Imports(as % of merchandise exports) in 1963?
Your answer should be compact. 15.15. What is the difference between the highest and the lowest Imports(as % of merchandise exports) of 1964?
Keep it short and to the point. 14.19. What is the difference between the highest and the lowest Imports(as % of merchandise exports) in 1965?
Offer a very short reply. 11.77. 